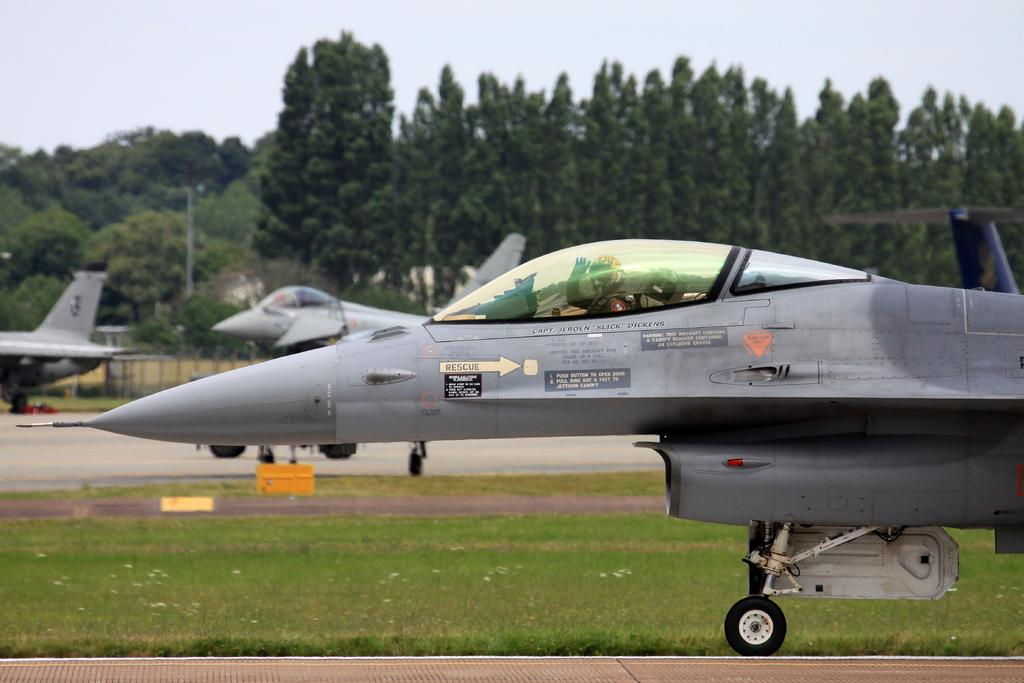What type of vehicles are on the ground in the image? There are airplanes on the ground in the image. What structures can be seen in the image? There are poles in the image. What type of vegetation is present in the image? There are trees and grass in the image. What part of the natural environment is visible in the image? The sky is visible in the image. What type of animals can be seen in the zoo in the image? There is no zoo present in the image, and therefore no animals can be observed. What emotion is being expressed by the love in the image? There is no reference to love or any emotions in the image. 